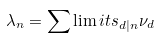<formula> <loc_0><loc_0><loc_500><loc_500>\lambda _ { n } = \sum \lim i t s _ { d | n } \nu _ { d }</formula> 